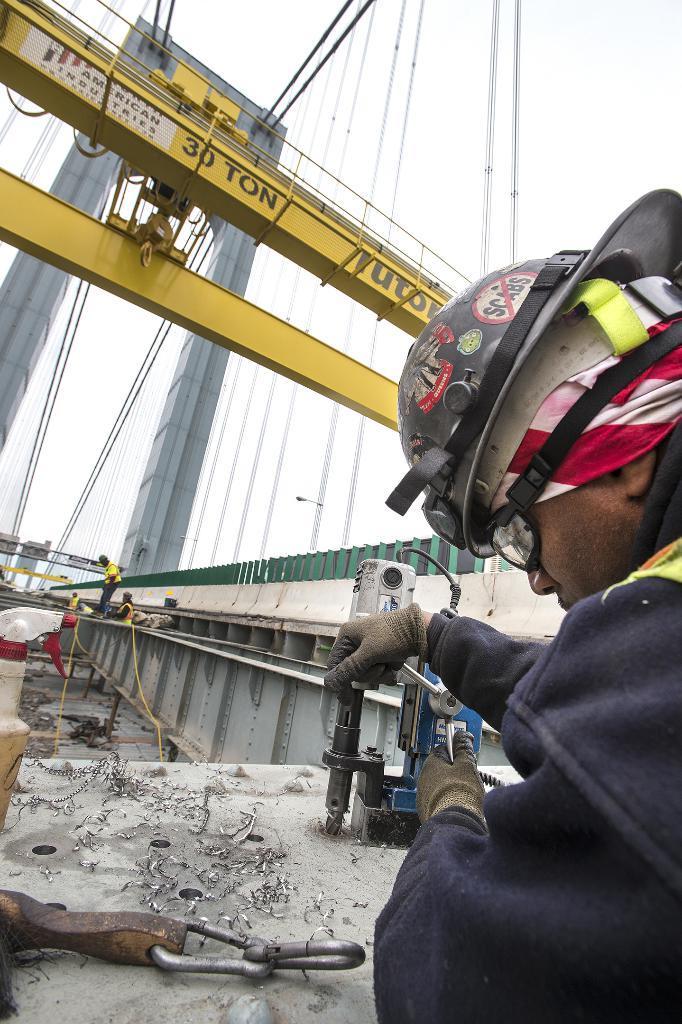How would you summarize this image in a sentence or two? On the right side of the image, we can see one person is wearing a helmet and gloves. And we can see he is holding some objects. In front of him, we can see a platform. On the platform, we can see one spray bottle and a few other objects. In the background, we can see the sky, railing, pole type structures, wires, pipes, few people and a few other objects. And we can see some text on the yellow color object. 